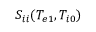<formula> <loc_0><loc_0><loc_500><loc_500>S _ { i i } ( T _ { e 1 } , T _ { i 0 } )</formula> 